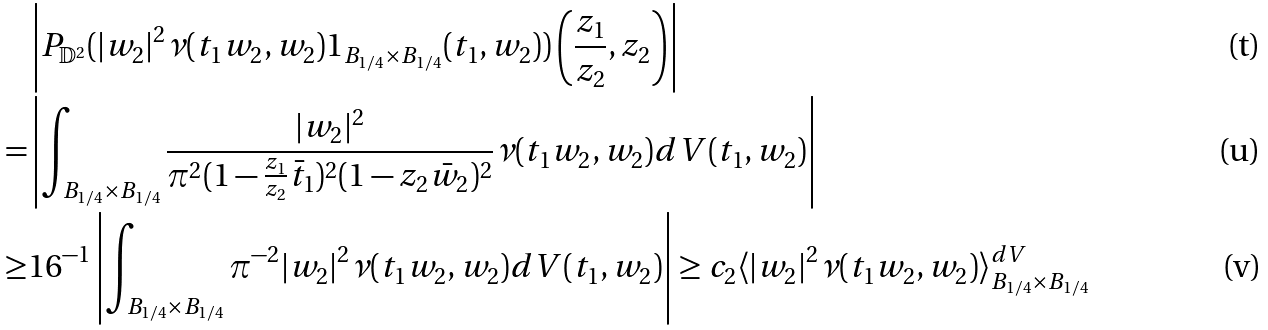Convert formula to latex. <formula><loc_0><loc_0><loc_500><loc_500>& \left | P _ { \mathbb { D } ^ { 2 } } ( | w _ { 2 } | ^ { 2 } { \nu ( t _ { 1 } w _ { 2 } , w _ { 2 } ) } 1 _ { B _ { 1 / 4 } \times B _ { 1 / 4 } } ( t _ { 1 } , w _ { 2 } ) ) \left ( \frac { z _ { 1 } } { z _ { 2 } } , z _ { 2 } \right ) \right | \\ = & \left | \int _ { B _ { 1 / 4 } \times B _ { 1 / 4 } } \frac { | w _ { 2 } | ^ { 2 } } { \pi ^ { 2 } ( 1 - \frac { z _ { 1 } } { z _ { 2 } } \bar { t } _ { 1 } ) ^ { 2 } ( 1 - z _ { 2 } \bar { w } _ { 2 } ) ^ { 2 } } { \nu ( t _ { 1 } w _ { 2 } , w _ { 2 } ) } d V ( t _ { 1 } , w _ { 2 } ) \right | \\ \geq & 1 6 ^ { - 1 } \left | \int _ { B _ { 1 / 4 } \times B _ { 1 / 4 } } \pi ^ { - 2 } { | w _ { 2 } | ^ { 2 } } { \nu ( t _ { 1 } w _ { 2 } , w _ { 2 } ) } d V ( t _ { 1 } , w _ { 2 } ) \right | \geq c _ { 2 } \langle | w _ { 2 } | ^ { 2 } \nu ( t _ { 1 } w _ { 2 } , w _ { 2 } ) \rangle ^ { d V } _ { B _ { 1 / 4 } \times B _ { 1 / 4 } }</formula> 